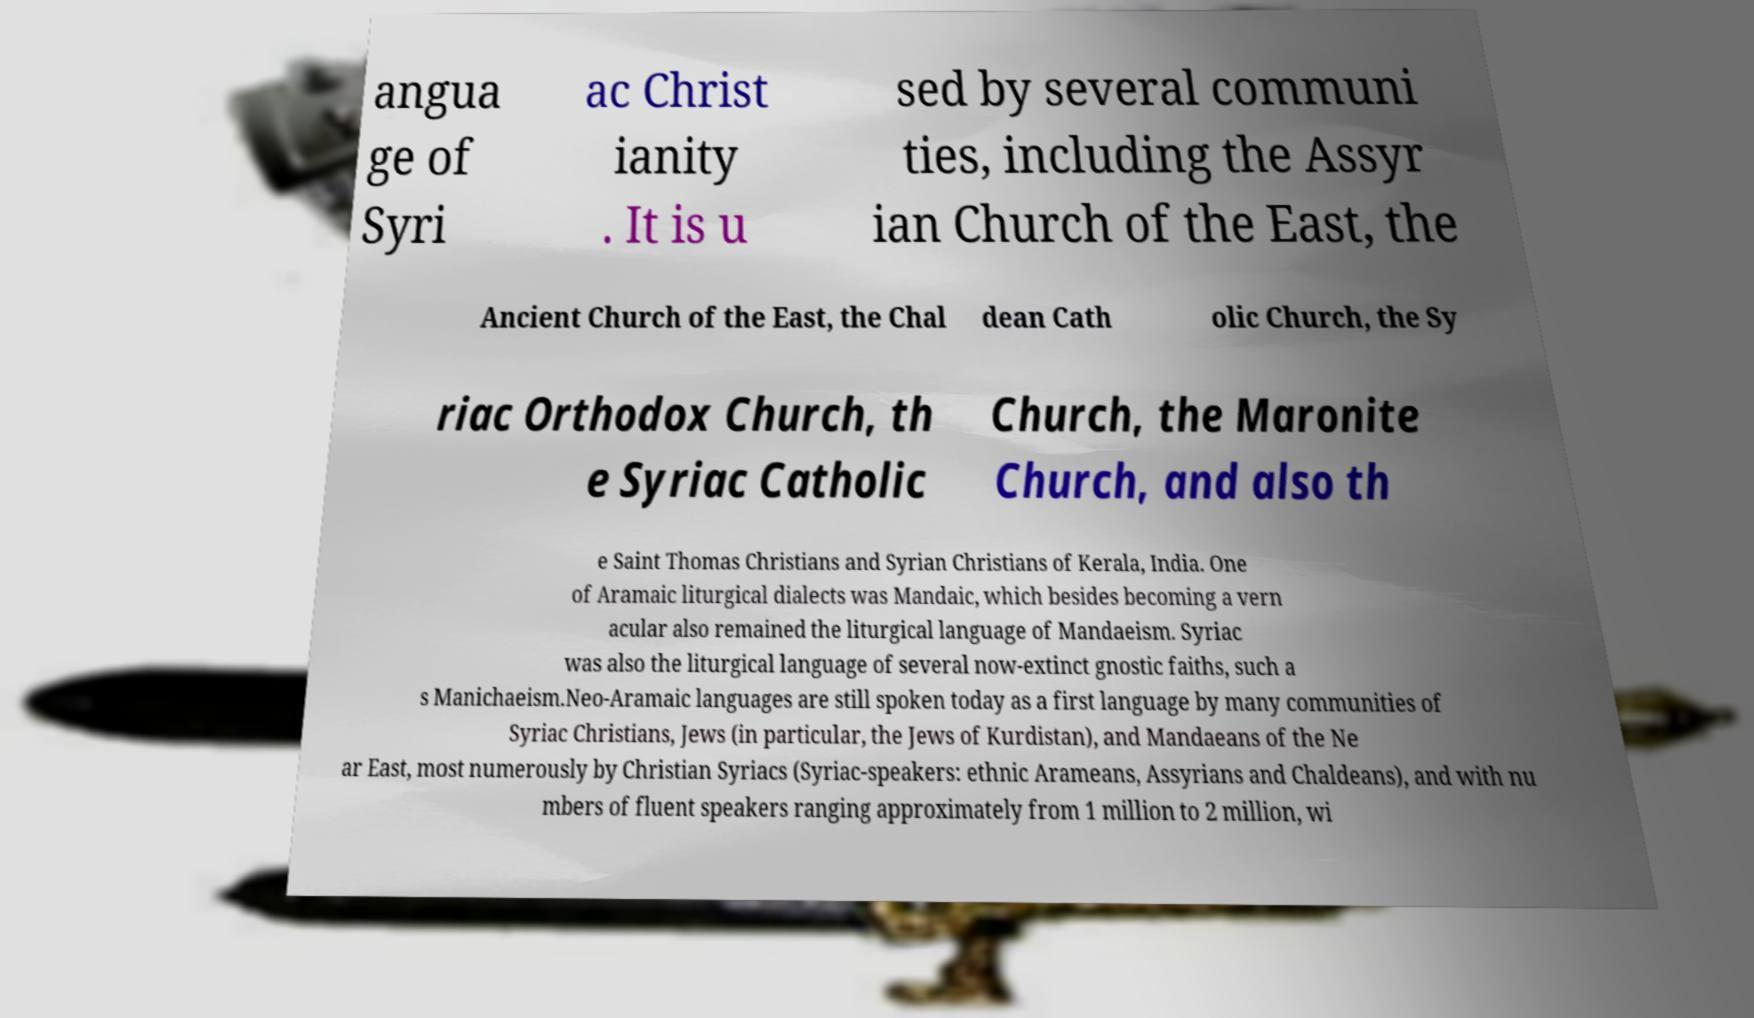Please identify and transcribe the text found in this image. angua ge of Syri ac Christ ianity . It is u sed by several communi ties, including the Assyr ian Church of the East, the Ancient Church of the East, the Chal dean Cath olic Church, the Sy riac Orthodox Church, th e Syriac Catholic Church, the Maronite Church, and also th e Saint Thomas Christians and Syrian Christians of Kerala, India. One of Aramaic liturgical dialects was Mandaic, which besides becoming a vern acular also remained the liturgical language of Mandaeism. Syriac was also the liturgical language of several now-extinct gnostic faiths, such a s Manichaeism.Neo-Aramaic languages are still spoken today as a first language by many communities of Syriac Christians, Jews (in particular, the Jews of Kurdistan), and Mandaeans of the Ne ar East, most numerously by Christian Syriacs (Syriac-speakers: ethnic Arameans, Assyrians and Chaldeans), and with nu mbers of fluent speakers ranging approximately from 1 million to 2 million, wi 